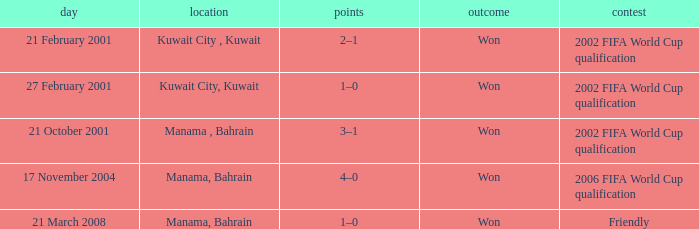What was the final score of the Friendly Competition in Manama, Bahrain? 1–0. 